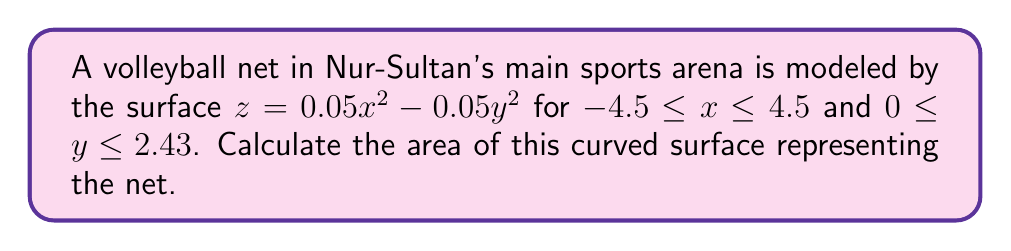Could you help me with this problem? To find the area of a curved surface, we use the surface area formula:

$$ A = \iint_R \sqrt{1 + (\frac{\partial z}{\partial x})^2 + (\frac{\partial z}{\partial y})^2} \, dA $$

Steps:
1) Find partial derivatives:
   $\frac{\partial z}{\partial x} = 0.1x$
   $\frac{\partial z}{\partial y} = -0.1y$

2) Substitute into the formula:
   $$ A = \int_{0}^{2.43} \int_{-4.5}^{4.5} \sqrt{1 + (0.1x)^2 + (-0.1y)^2} \, dx \, dy $$

3) Simplify the integrand:
   $$ A = \int_{0}^{2.43} \int_{-4.5}^{4.5} \sqrt{1 + 0.01x^2 + 0.01y^2} \, dx \, dy $$

4) This integral is complex to solve analytically. We can use numerical integration methods or mathematical software to evaluate it.

5) Using numerical integration, we find:
   $$ A \approx 22.1796 \, \text{m}^2 $$
Answer: $22.1796 \, \text{m}^2$ 